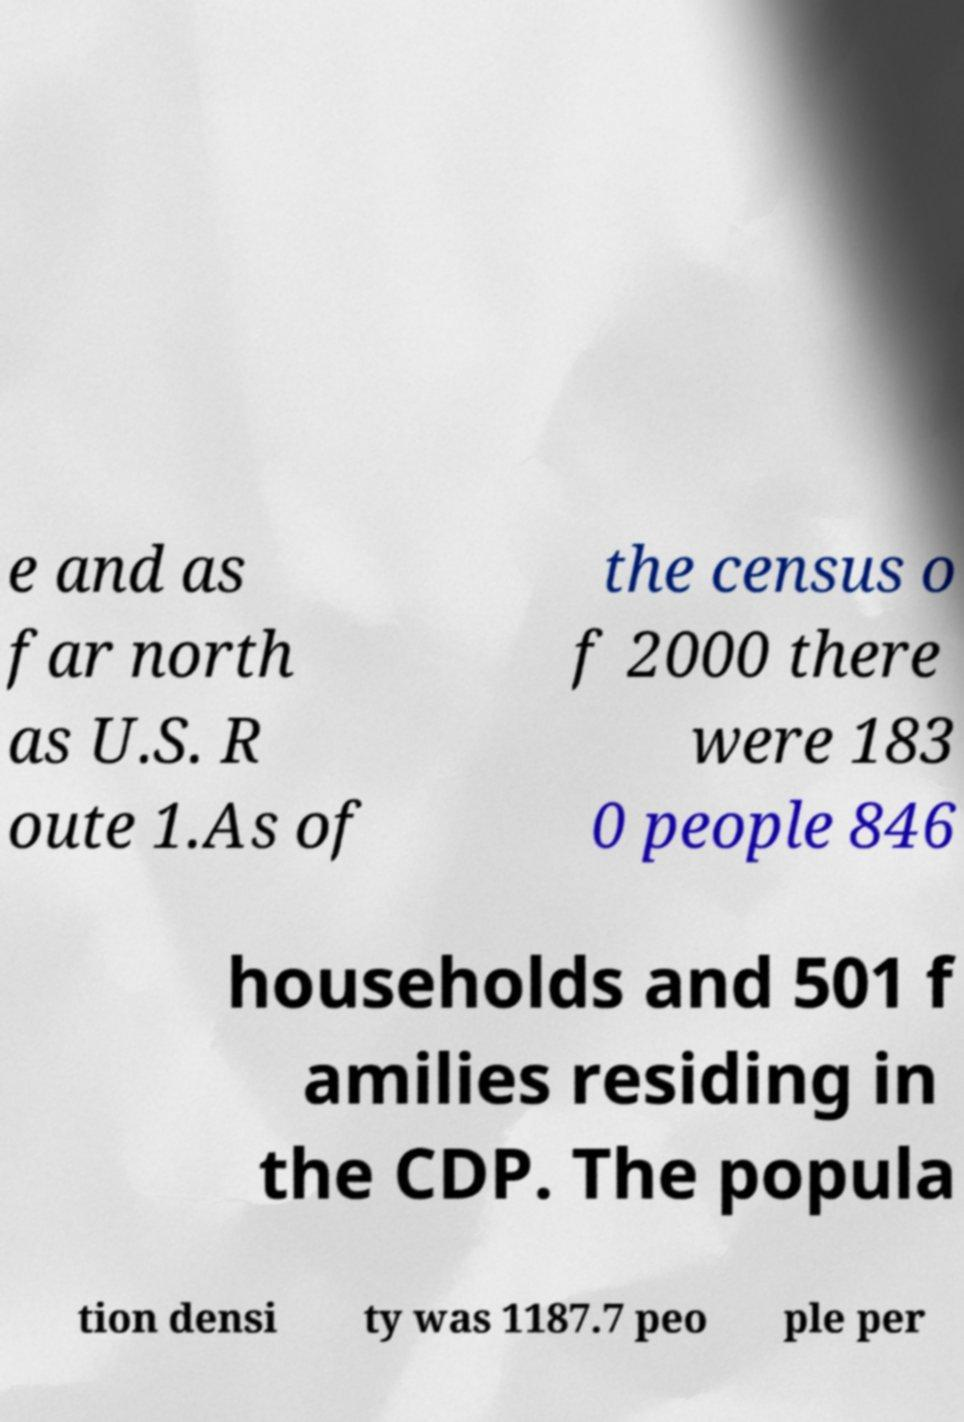Please read and relay the text visible in this image. What does it say? e and as far north as U.S. R oute 1.As of the census o f 2000 there were 183 0 people 846 households and 501 f amilies residing in the CDP. The popula tion densi ty was 1187.7 peo ple per 